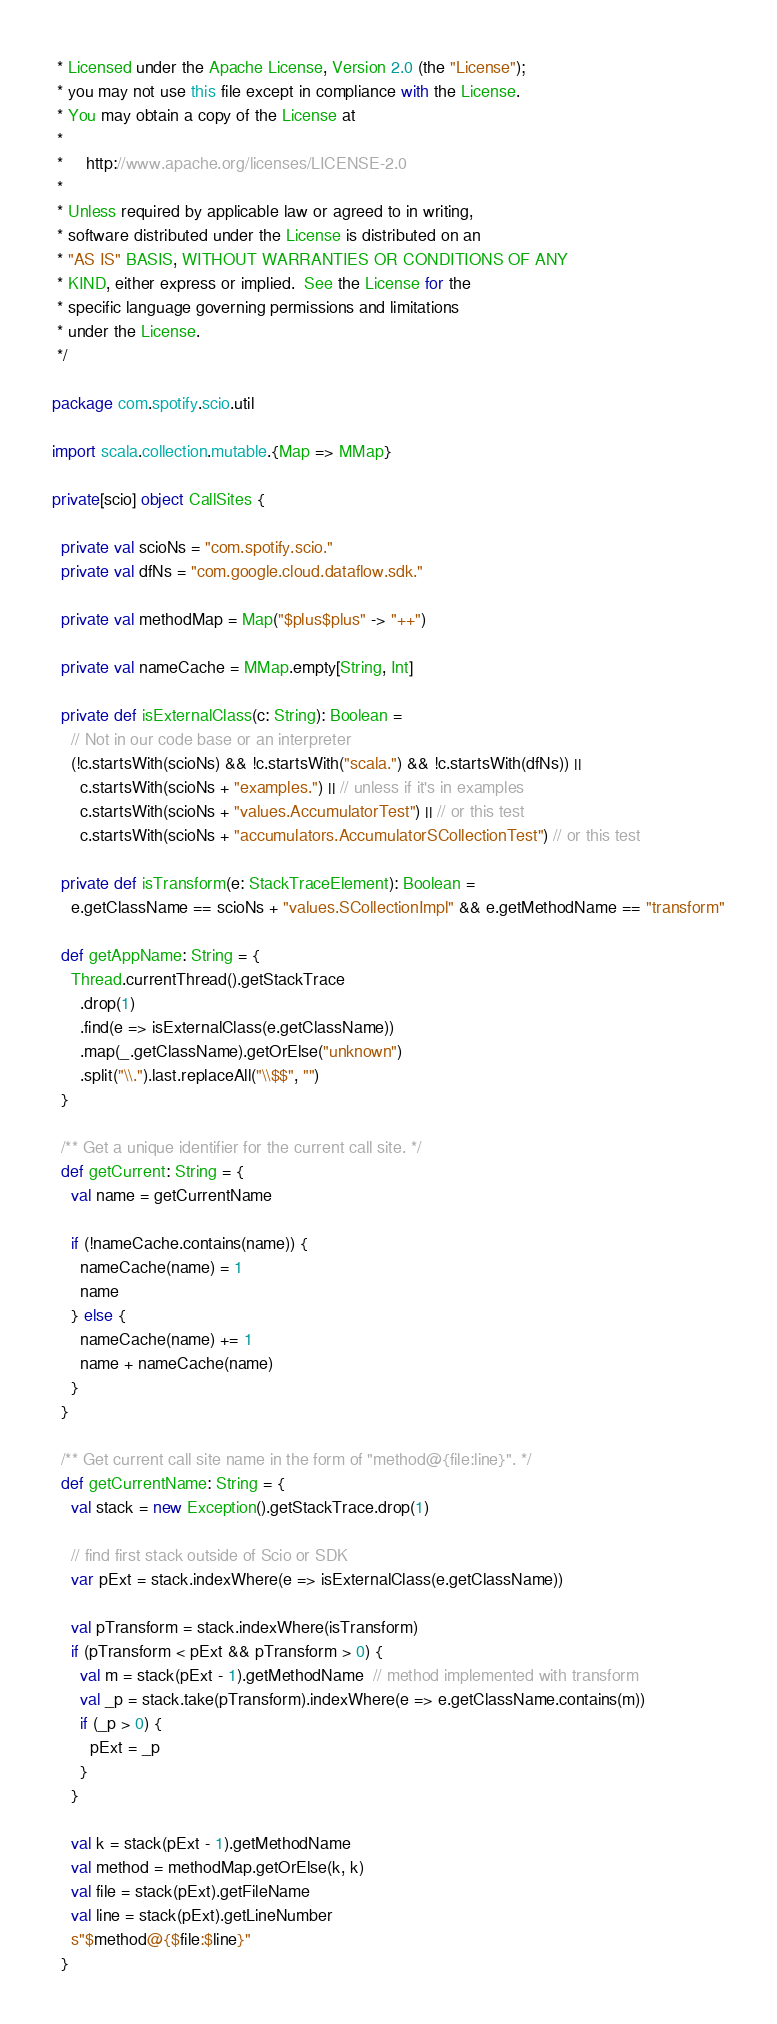<code> <loc_0><loc_0><loc_500><loc_500><_Scala_> * Licensed under the Apache License, Version 2.0 (the "License");
 * you may not use this file except in compliance with the License.
 * You may obtain a copy of the License at
 *
 *     http://www.apache.org/licenses/LICENSE-2.0
 *
 * Unless required by applicable law or agreed to in writing,
 * software distributed under the License is distributed on an
 * "AS IS" BASIS, WITHOUT WARRANTIES OR CONDITIONS OF ANY
 * KIND, either express or implied.  See the License for the
 * specific language governing permissions and limitations
 * under the License.
 */

package com.spotify.scio.util

import scala.collection.mutable.{Map => MMap}

private[scio] object CallSites {

  private val scioNs = "com.spotify.scio."
  private val dfNs = "com.google.cloud.dataflow.sdk."

  private val methodMap = Map("$plus$plus" -> "++")

  private val nameCache = MMap.empty[String, Int]

  private def isExternalClass(c: String): Boolean =
    // Not in our code base or an interpreter
    (!c.startsWith(scioNs) && !c.startsWith("scala.") && !c.startsWith(dfNs)) ||
      c.startsWith(scioNs + "examples.") || // unless if it's in examples
      c.startsWith(scioNs + "values.AccumulatorTest") || // or this test
      c.startsWith(scioNs + "accumulators.AccumulatorSCollectionTest") // or this test

  private def isTransform(e: StackTraceElement): Boolean =
    e.getClassName == scioNs + "values.SCollectionImpl" && e.getMethodName == "transform"

  def getAppName: String = {
    Thread.currentThread().getStackTrace
      .drop(1)
      .find(e => isExternalClass(e.getClassName))
      .map(_.getClassName).getOrElse("unknown")
      .split("\\.").last.replaceAll("\\$$", "")
  }

  /** Get a unique identifier for the current call site. */
  def getCurrent: String = {
    val name = getCurrentName

    if (!nameCache.contains(name)) {
      nameCache(name) = 1
      name
    } else {
      nameCache(name) += 1
      name + nameCache(name)
    }
  }

  /** Get current call site name in the form of "method@{file:line}". */
  def getCurrentName: String = {
    val stack = new Exception().getStackTrace.drop(1)

    // find first stack outside of Scio or SDK
    var pExt = stack.indexWhere(e => isExternalClass(e.getClassName))

    val pTransform = stack.indexWhere(isTransform)
    if (pTransform < pExt && pTransform > 0) {
      val m = stack(pExt - 1).getMethodName  // method implemented with transform
      val _p = stack.take(pTransform).indexWhere(e => e.getClassName.contains(m))
      if (_p > 0) {
        pExt = _p
      }
    }

    val k = stack(pExt - 1).getMethodName
    val method = methodMap.getOrElse(k, k)
    val file = stack(pExt).getFileName
    val line = stack(pExt).getLineNumber
    s"$method@{$file:$line}"
  }
</code> 